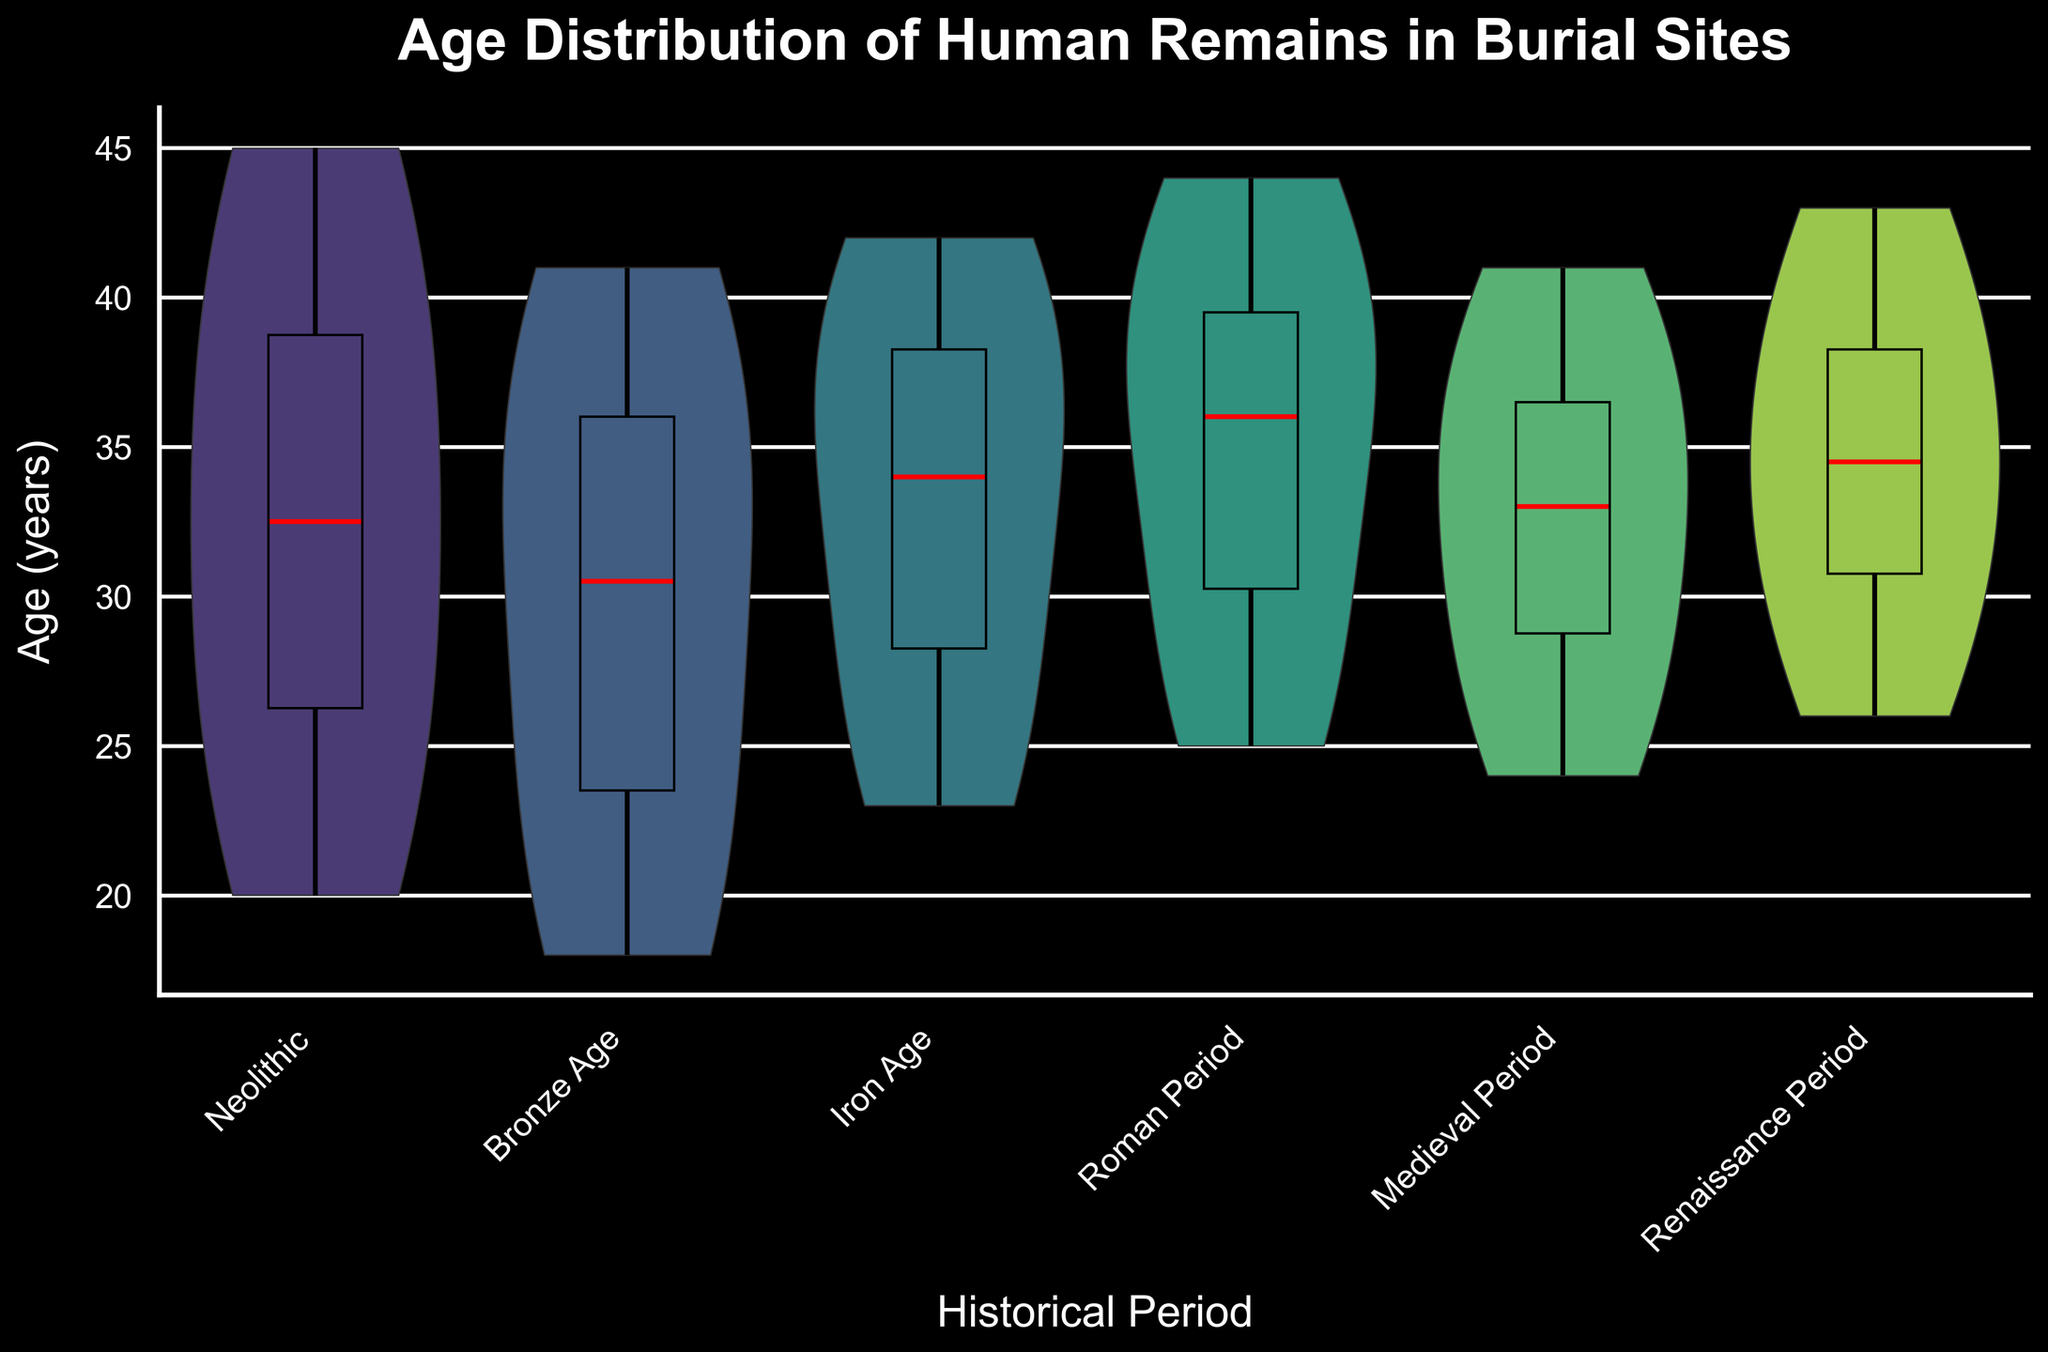What is the title of the figure? The title is displayed at the top of the chart in the largest and boldest font. It summarizes the chart's content.
Answer: Age Distribution of Human Remains in Burial Sites How are the data points distributed across the different historical periods? By looking at the distribution in each violin plot, you can see the density and range of ages for each period. Wider areas represent higher density of ages.
Answer: Distributed widely What is the median age of remains found in the Iron Age burial sites? You can find the median age by looking at the red line inside the box plot for the Iron Age group.
Answer: 36 Which historical period has the highest overall age range for the human remains? The age range can be determined by looking at the extent of the whiskers in each box plot overlay. The period with the largest gap between the minimum and maximum values has the highest range.
Answer: Neolithic Are there any periods where the median age is above 40 years? You need to examine the red lines in the box plots to see if any periods have a median age above 40. Since all medians are clearly below this value, there are none.
Answer: No Which period has a higher median age, the Bronze Age or the Renaissance Period? Compare the red lines in the box plots of both periods to determine which one is higher.
Answer: Renaissance Period During which period do the ages of human remains show the least variance? Variance can be inferred from the width of the violin and the box plot whiskers; the smaller the spread and narrower the violin, the lower the variance is.
Answer: Medieval Period Is the age distribution in the Roman Period symmetrical or skewed? By observing the shape of the violin plot for the Roman Period, you can determine if it is symmetrical or skewed towards one side.
Answer: Symmetrical Which historical period has the youngest median age of human remains? The period with the lowest red line in the box plot overlay represents the youngest median age.
Answer: Bronze Age 